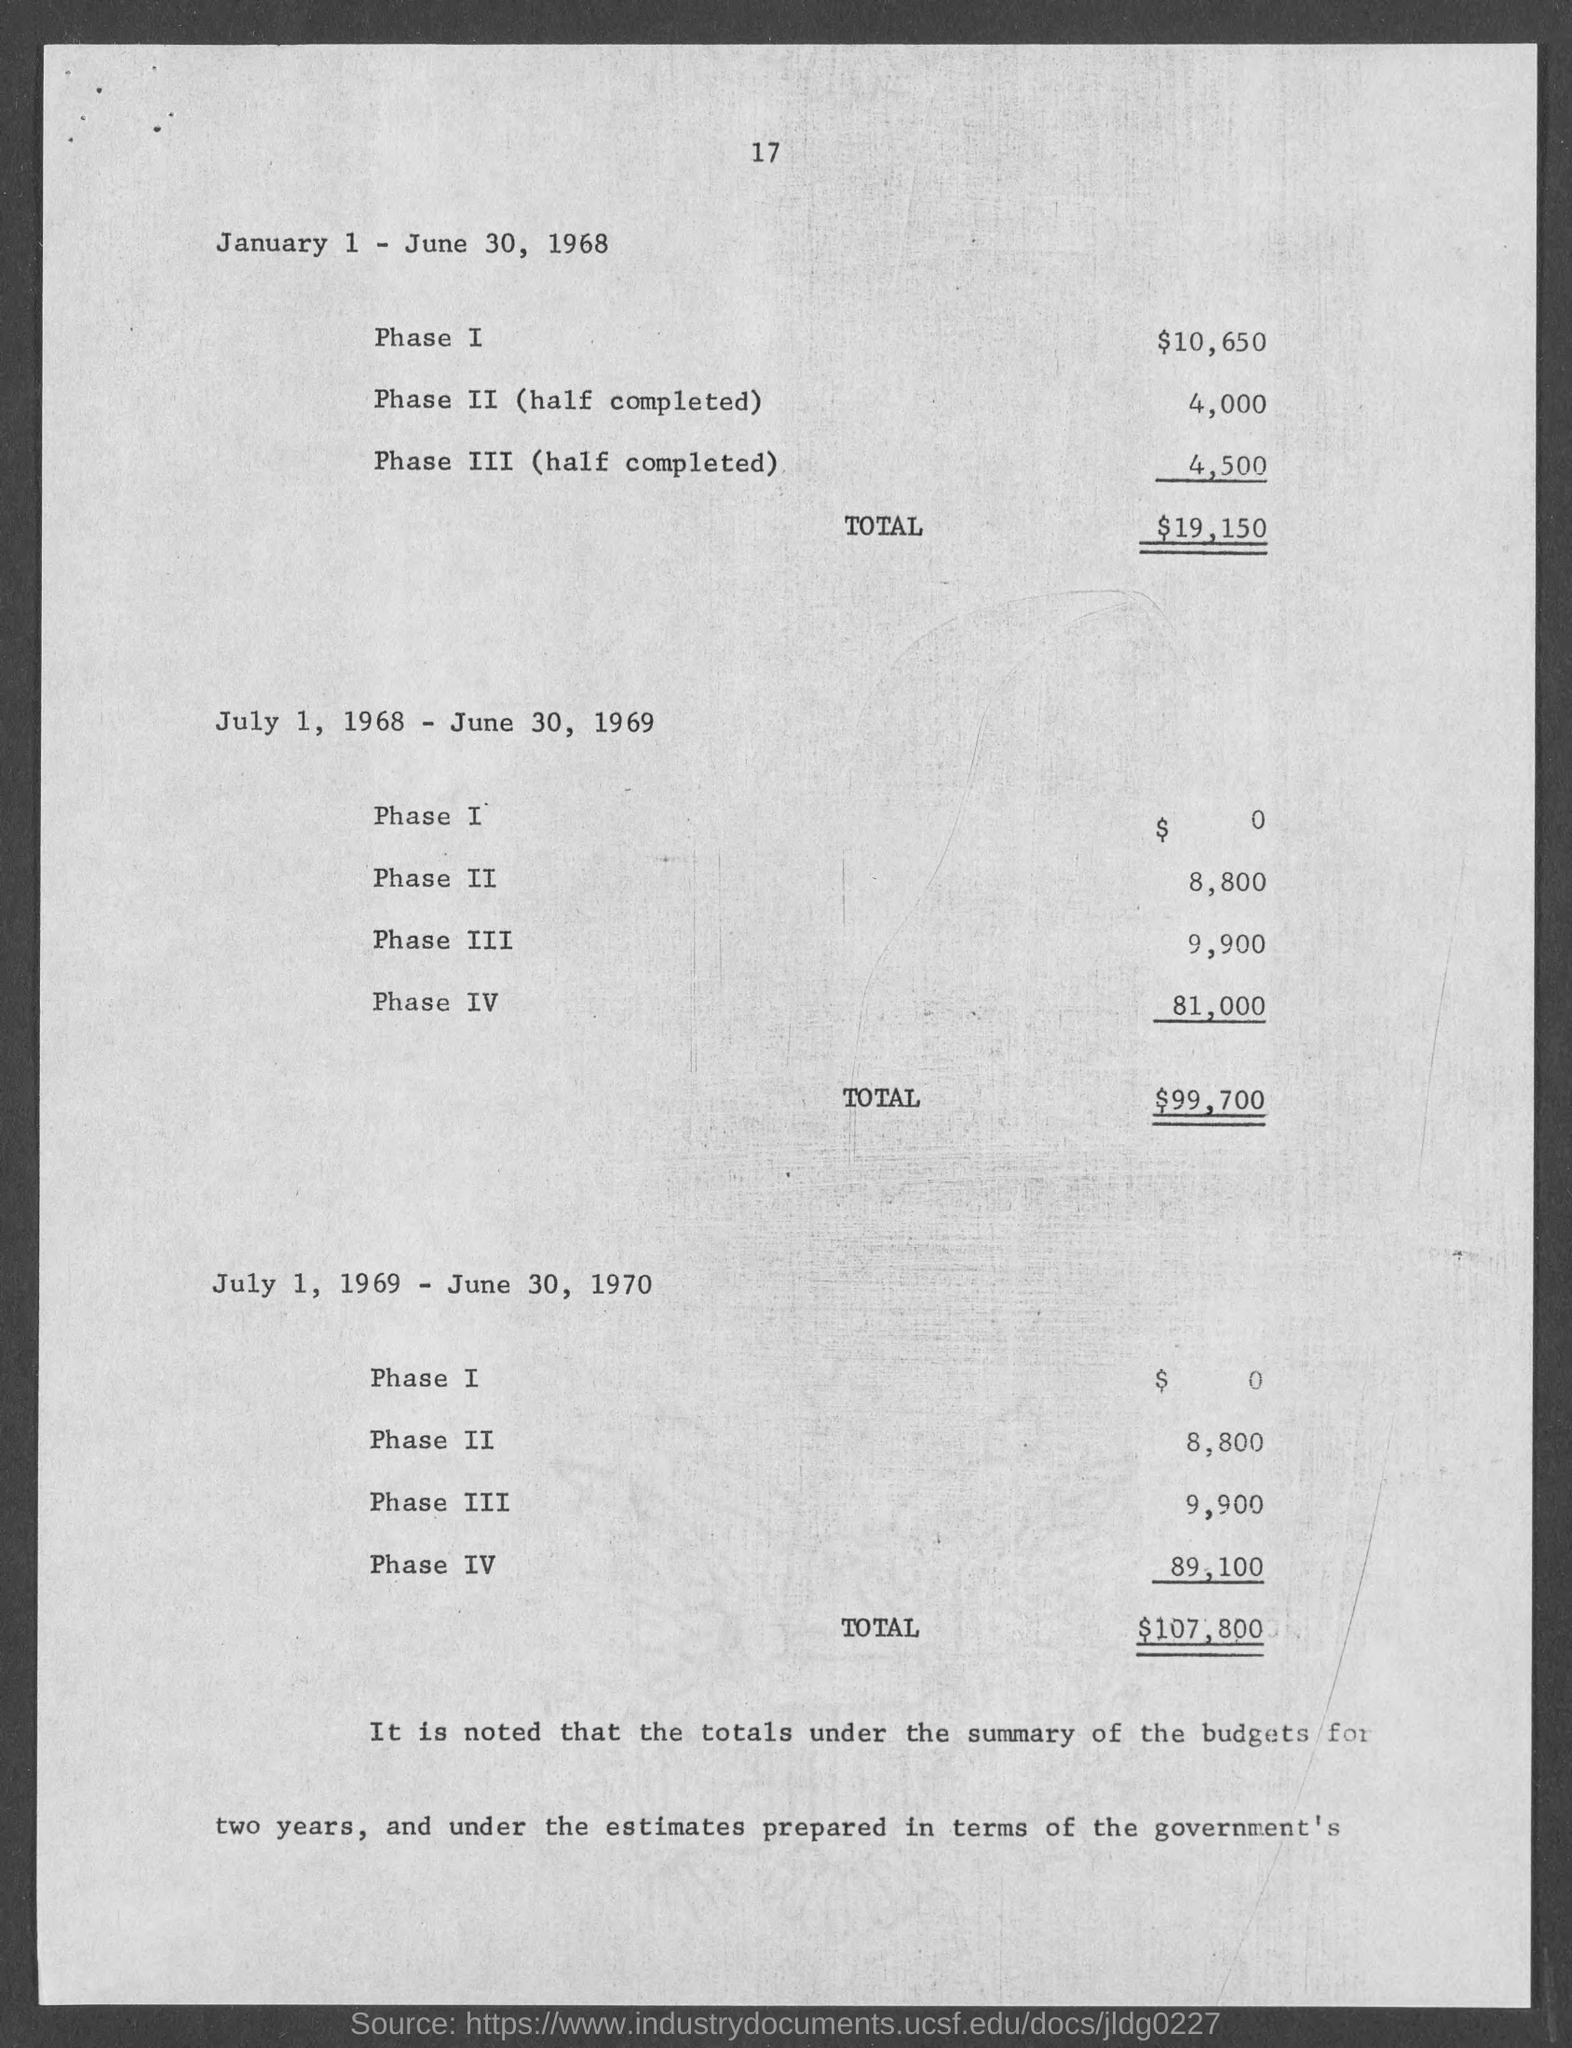What is the Cost of Phase I for January 1 - June 30, 1968?
Ensure brevity in your answer.  $10,650. What is the Cost of Phase II (half completed)January 1 - June 30, 1968?
Offer a terse response. 4,000. What is the Cost of Phase III  (half completed) January 1 - June 30, 1968?
Offer a very short reply. 4,500. What is the Total for January 1 - June 30, 1968?
Your answer should be compact. $19,150. What is the Cost of Phase I for July 1, 1968 - JUNE 30, 1969?
Your response must be concise. $0. What is the cost of Phase II for July 1, 1968 - JUNE 30, 1969?
Make the answer very short. 8,800. What is the cost of Phase III for July 1, 1968 - JUNE 30, 1969?
Keep it short and to the point. 9,900. What is the cost of Phase IV for July 1, 1968 - JUNE 30, 1969?
Offer a very short reply. 81,000. What is the Total for July 1, 1968 - JUNE 30, 1969?
Ensure brevity in your answer.  99,700. What is the Total for July 1, 1969 - JUNE 30, 1970?
Offer a terse response. $107,800. 